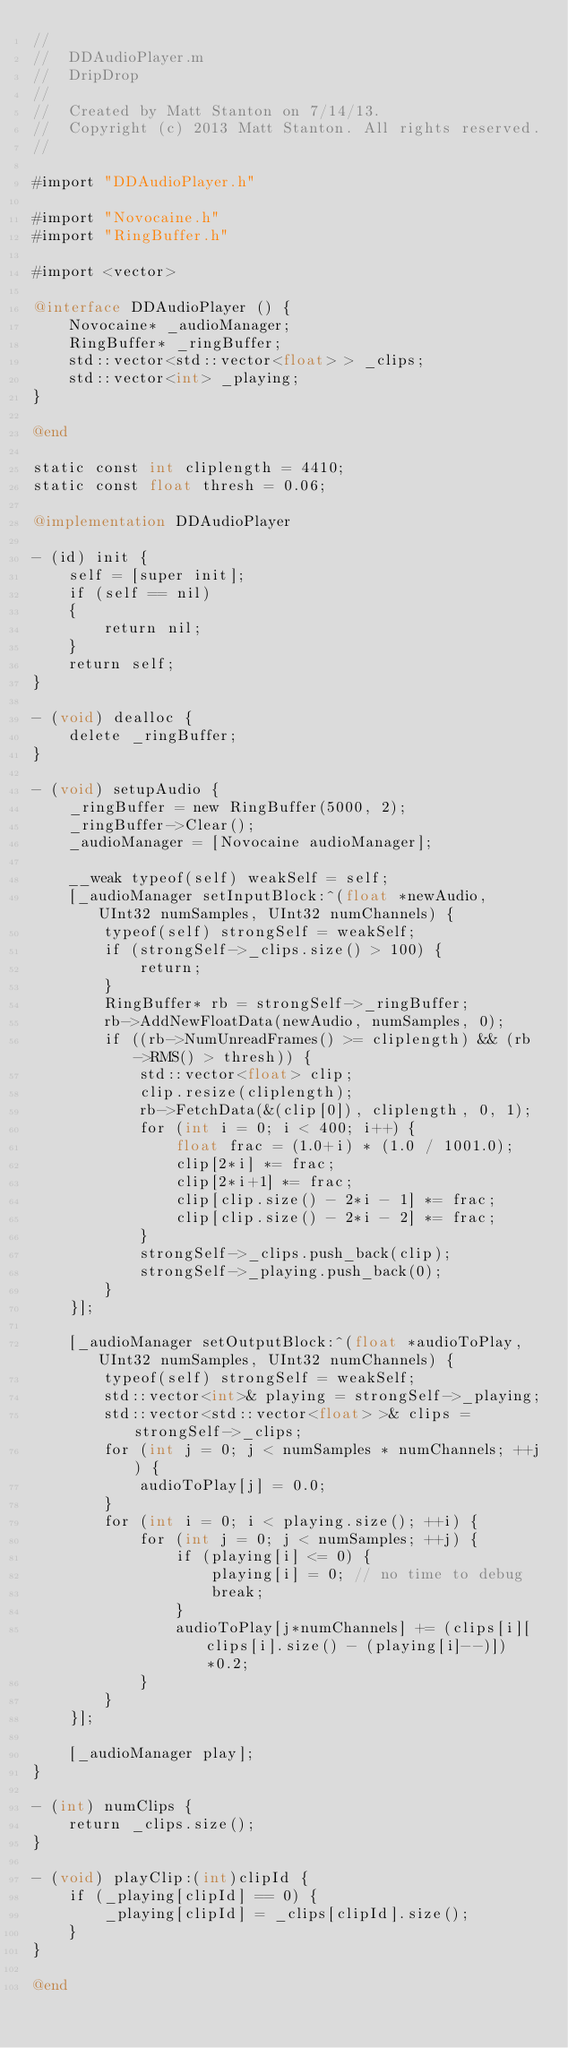Convert code to text. <code><loc_0><loc_0><loc_500><loc_500><_ObjectiveC_>//
//  DDAudioPlayer.m
//  DripDrop
//
//  Created by Matt Stanton on 7/14/13.
//  Copyright (c) 2013 Matt Stanton. All rights reserved.
//

#import "DDAudioPlayer.h"

#import "Novocaine.h"
#import "RingBuffer.h"

#import <vector>

@interface DDAudioPlayer () {
    Novocaine* _audioManager;
    RingBuffer* _ringBuffer;
    std::vector<std::vector<float> > _clips;
    std::vector<int> _playing;
}

@end

static const int cliplength = 4410;
static const float thresh = 0.06;

@implementation DDAudioPlayer

- (id) init {
    self = [super init];
    if (self == nil)
    {
        return nil;
    }
    return self;
}

- (void) dealloc {
    delete _ringBuffer;
}

- (void) setupAudio {
    _ringBuffer = new RingBuffer(5000, 2);
    _ringBuffer->Clear();
    _audioManager = [Novocaine audioManager];
    
    __weak typeof(self) weakSelf = self;
    [_audioManager setInputBlock:^(float *newAudio, UInt32 numSamples, UInt32 numChannels) {
        typeof(self) strongSelf = weakSelf;
        if (strongSelf->_clips.size() > 100) {
            return;
        }
        RingBuffer* rb = strongSelf->_ringBuffer;
        rb->AddNewFloatData(newAudio, numSamples, 0);
        if ((rb->NumUnreadFrames() >= cliplength) && (rb->RMS() > thresh)) {
            std::vector<float> clip;
            clip.resize(cliplength);
            rb->FetchData(&(clip[0]), cliplength, 0, 1);
            for (int i = 0; i < 400; i++) {
                float frac = (1.0+i) * (1.0 / 1001.0);
                clip[2*i] *= frac;
                clip[2*i+1] *= frac;
                clip[clip.size() - 2*i - 1] *= frac;
                clip[clip.size() - 2*i - 2] *= frac;
            }
            strongSelf->_clips.push_back(clip);
            strongSelf->_playing.push_back(0);
        }
    }];
    
    [_audioManager setOutputBlock:^(float *audioToPlay, UInt32 numSamples, UInt32 numChannels) {
        typeof(self) strongSelf = weakSelf;
        std::vector<int>& playing = strongSelf->_playing;
        std::vector<std::vector<float> >& clips = strongSelf->_clips;
        for (int j = 0; j < numSamples * numChannels; ++j) {
            audioToPlay[j] = 0.0;
        }
        for (int i = 0; i < playing.size(); ++i) {
            for (int j = 0; j < numSamples; ++j) {
                if (playing[i] <= 0) {
                    playing[i] = 0; // no time to debug
                    break;
                }
                audioToPlay[j*numChannels] += (clips[i][clips[i].size() - (playing[i]--)])*0.2;
            }
        }
    }];
    
    [_audioManager play];
}

- (int) numClips {
    return _clips.size();
}

- (void) playClip:(int)clipId {
    if (_playing[clipId] == 0) {
        _playing[clipId] = _clips[clipId].size();
    }
}

@end
</code> 